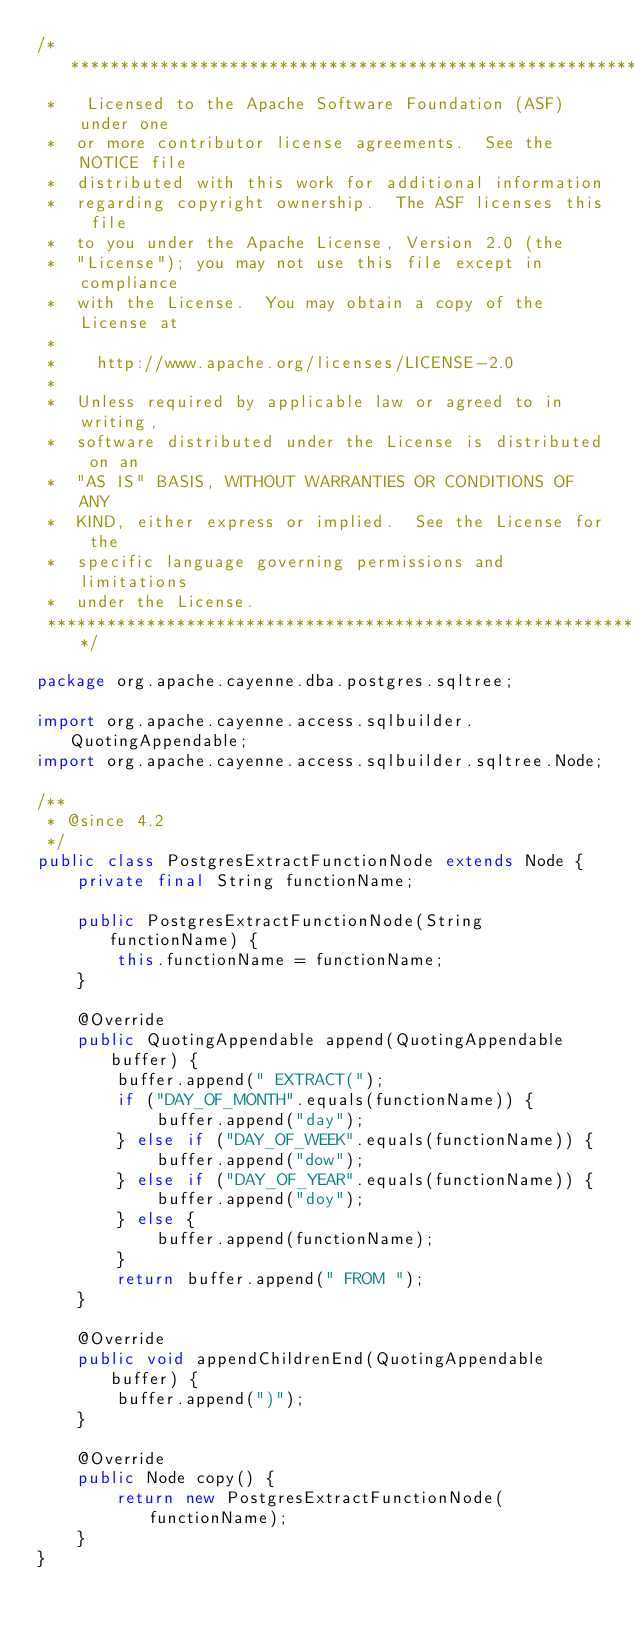Convert code to text. <code><loc_0><loc_0><loc_500><loc_500><_Java_>/*****************************************************************
 *   Licensed to the Apache Software Foundation (ASF) under one
 *  or more contributor license agreements.  See the NOTICE file
 *  distributed with this work for additional information
 *  regarding copyright ownership.  The ASF licenses this file
 *  to you under the Apache License, Version 2.0 (the
 *  "License"); you may not use this file except in compliance
 *  with the License.  You may obtain a copy of the License at
 *
 *    http://www.apache.org/licenses/LICENSE-2.0
 *
 *  Unless required by applicable law or agreed to in writing,
 *  software distributed under the License is distributed on an
 *  "AS IS" BASIS, WITHOUT WARRANTIES OR CONDITIONS OF ANY
 *  KIND, either express or implied.  See the License for the
 *  specific language governing permissions and limitations
 *  under the License.
 ****************************************************************/

package org.apache.cayenne.dba.postgres.sqltree;

import org.apache.cayenne.access.sqlbuilder.QuotingAppendable;
import org.apache.cayenne.access.sqlbuilder.sqltree.Node;

/**
 * @since 4.2
 */
public class PostgresExtractFunctionNode extends Node {
    private final String functionName;

    public PostgresExtractFunctionNode(String functionName) {
        this.functionName = functionName;
    }

    @Override
    public QuotingAppendable append(QuotingAppendable buffer) {
        buffer.append(" EXTRACT(");
        if ("DAY_OF_MONTH".equals(functionName)) {
            buffer.append("day");
        } else if ("DAY_OF_WEEK".equals(functionName)) {
            buffer.append("dow");
        } else if ("DAY_OF_YEAR".equals(functionName)) {
            buffer.append("doy");
        } else {
            buffer.append(functionName);
        }
        return buffer.append(" FROM ");
    }

    @Override
    public void appendChildrenEnd(QuotingAppendable buffer) {
        buffer.append(")");
    }

    @Override
    public Node copy() {
        return new PostgresExtractFunctionNode(functionName);
    }
}
</code> 